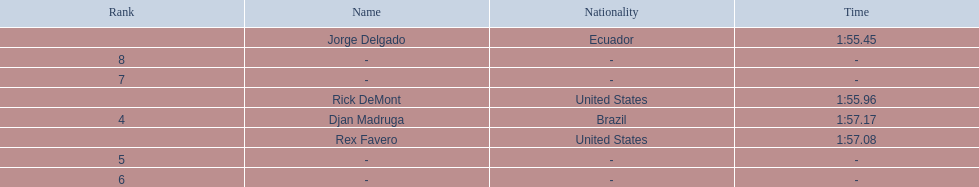How many ranked swimmers were from the united states? 2. 